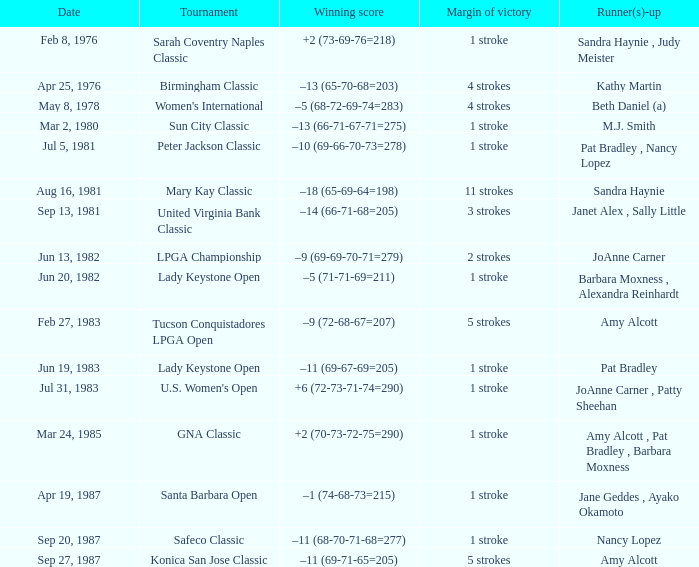What is the winning score when the tournament is safeco classic? –11 (68-70-71-68=277). 